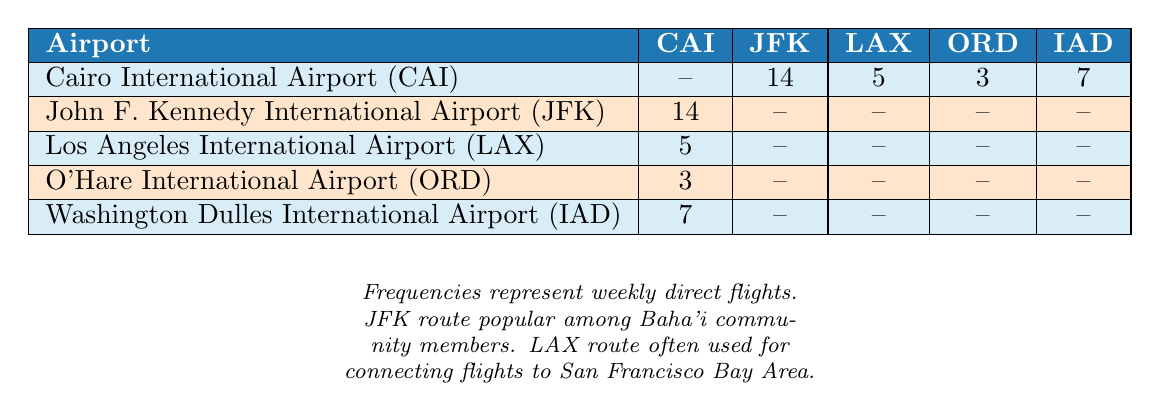What's the number of weekly direct flights from Cairo to John F. Kennedy International Airport? The table lists the direct flights from Cairo International Airport (CAI) to JFK as 14. This is directly found in the cell corresponding to CAI and JFK.
Answer: 14 How many weekly direct flights are there from Los Angeles International Airport to Cairo? The table shows that there are 5 weekly direct flights from LAX to CAI. This is seen in the cell where LAX intersects with CAI.
Answer: 5 What is the total number of weekly direct flights from Cairo to U.S. airports listed in the table? From the table, we can add the direct flights from CAI to all U.S. airports: 14 (JFK) + 5 (LAX) + 3 (ORD) + 7 (IAD) = 29.
Answer: 29 Is there any weekly direct flight from John F. Kennedy International Airport to Cairo? The table shows a value of 14 from JFK to CAI, indicating there are indeed direct flights.
Answer: Yes Which U.S. airport has the least number of weekly direct flights from Cairo? The flights from CAI to ORD show the least value of 3, compared to LAX (5) and IAD (7) in the table.
Answer: O'Hare International Airport What can be inferred about the popularity of direct flights from Cairo to JFK compared to other U.S. airports? The direct flights from Cairo to JFK are significantly higher (14) than to any other airport, suggesting it is the most popular route for travelers.
Answer: JFK is the most popular route If we wanted to find the average number of weekly flights from Cairo to the selected U.S. airports, what would that be? To find the average, we sum the flights from CAI to the U.S. airports: 14 + 5 + 3 + 7 = 29. Then, divide this total by the 4 routes: 29 / 4 = 7.25.
Answer: 7.25 How many weekly direct flights from Cairo to Washington Dulles International Airport are there? Directly from the table, the number of flights from CAI to IAD is indicated as 7.
Answer: 7 What is the relationship between the number of flights from Cairo to Los Angeles and Cairo to O'Hare? Comparing values in the table, CAI to LAX has 5 flights while CAI to ORD has 3 flights. This indicates that the route to LAX has more flights than to ORD.
Answer: More flights to LAX 